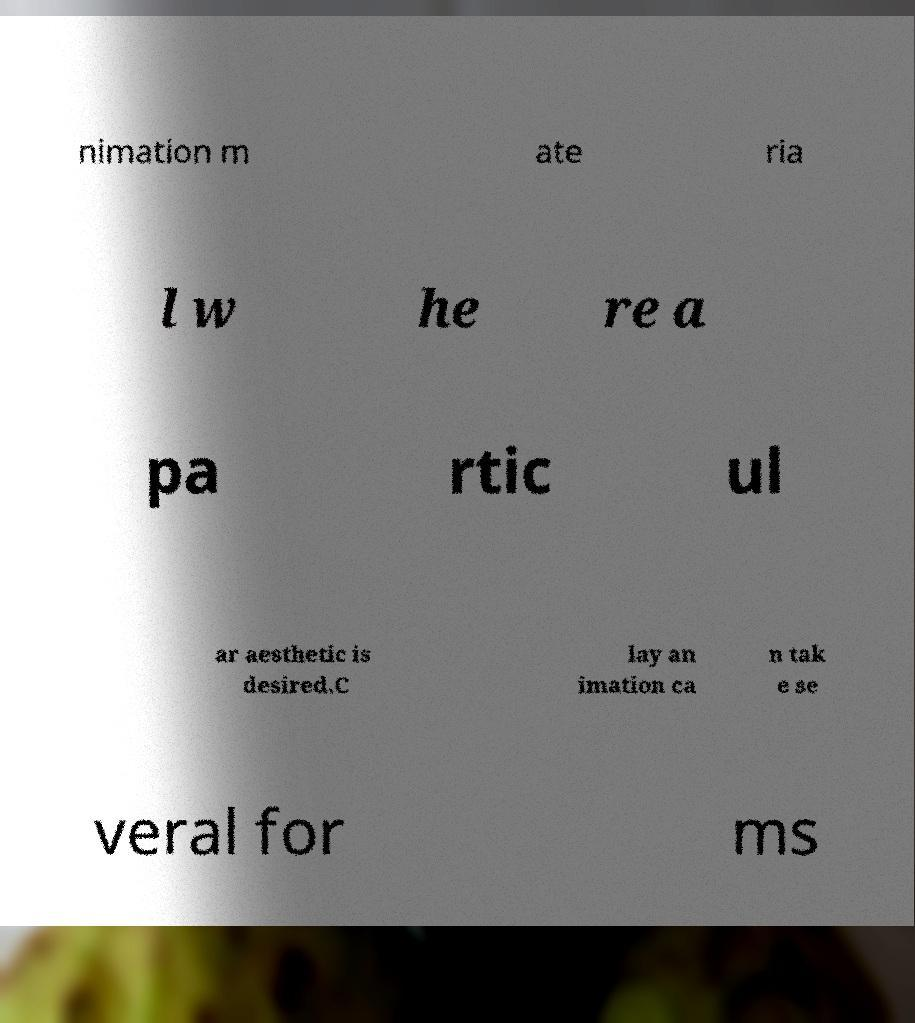Can you read and provide the text displayed in the image?This photo seems to have some interesting text. Can you extract and type it out for me? nimation m ate ria l w he re a pa rtic ul ar aesthetic is desired.C lay an imation ca n tak e se veral for ms 